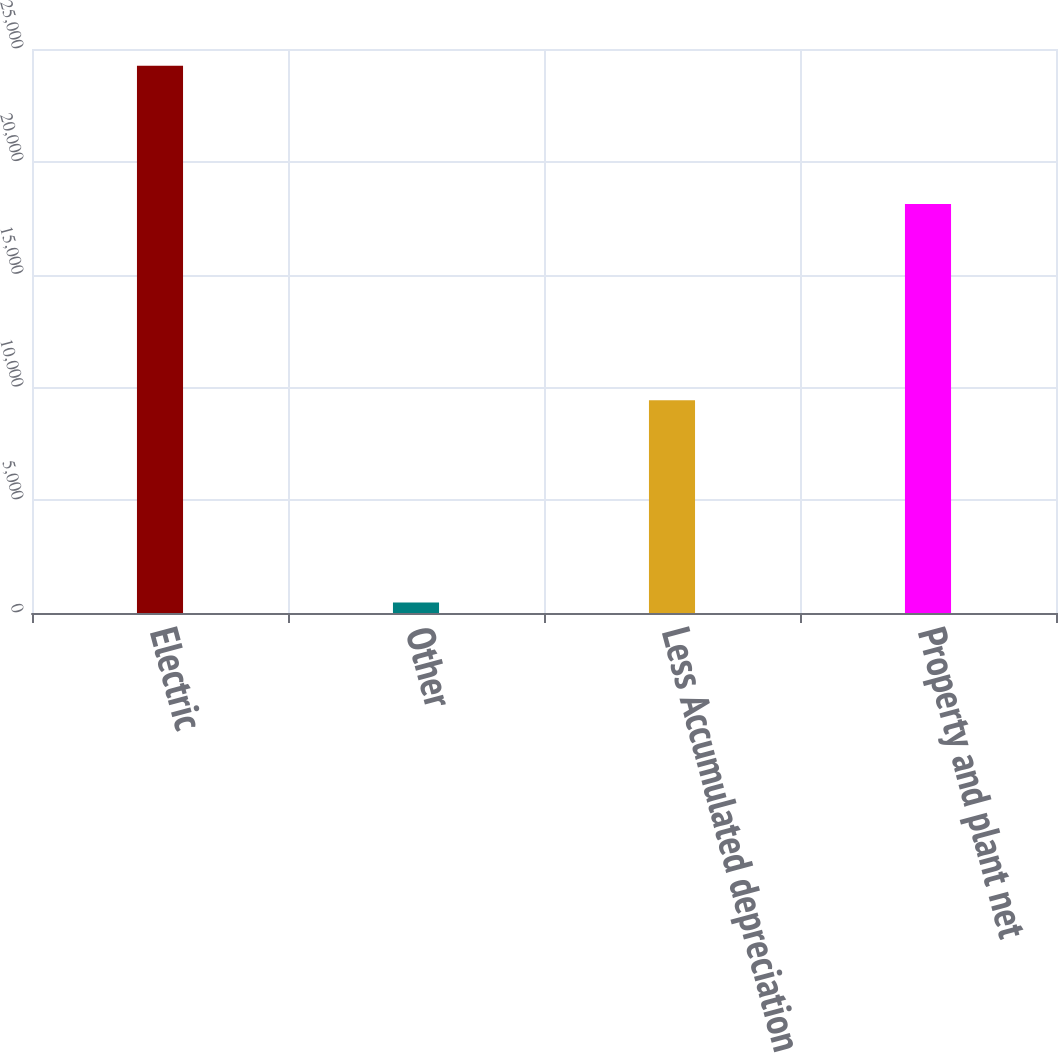Convert chart. <chart><loc_0><loc_0><loc_500><loc_500><bar_chart><fcel>Electric<fcel>Other<fcel>Less Accumulated depreciation<fcel>Property and plant net<nl><fcel>24256<fcel>466<fcel>9429<fcel>18127<nl></chart> 